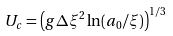<formula> <loc_0><loc_0><loc_500><loc_500>U _ { c } = \left ( g \Delta \xi ^ { 2 } \ln ( a _ { 0 } / \xi ) \right ) ^ { 1 / 3 }</formula> 